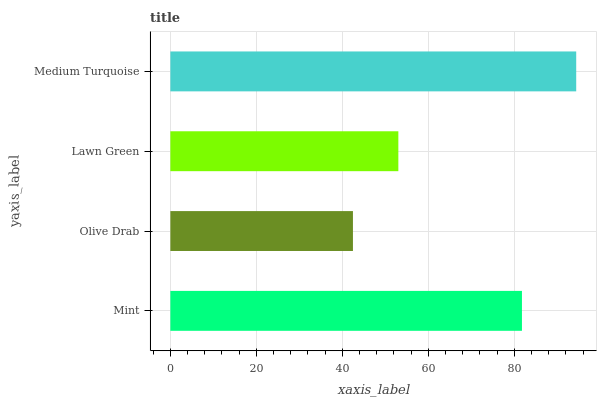Is Olive Drab the minimum?
Answer yes or no. Yes. Is Medium Turquoise the maximum?
Answer yes or no. Yes. Is Lawn Green the minimum?
Answer yes or no. No. Is Lawn Green the maximum?
Answer yes or no. No. Is Lawn Green greater than Olive Drab?
Answer yes or no. Yes. Is Olive Drab less than Lawn Green?
Answer yes or no. Yes. Is Olive Drab greater than Lawn Green?
Answer yes or no. No. Is Lawn Green less than Olive Drab?
Answer yes or no. No. Is Mint the high median?
Answer yes or no. Yes. Is Lawn Green the low median?
Answer yes or no. Yes. Is Lawn Green the high median?
Answer yes or no. No. Is Medium Turquoise the low median?
Answer yes or no. No. 